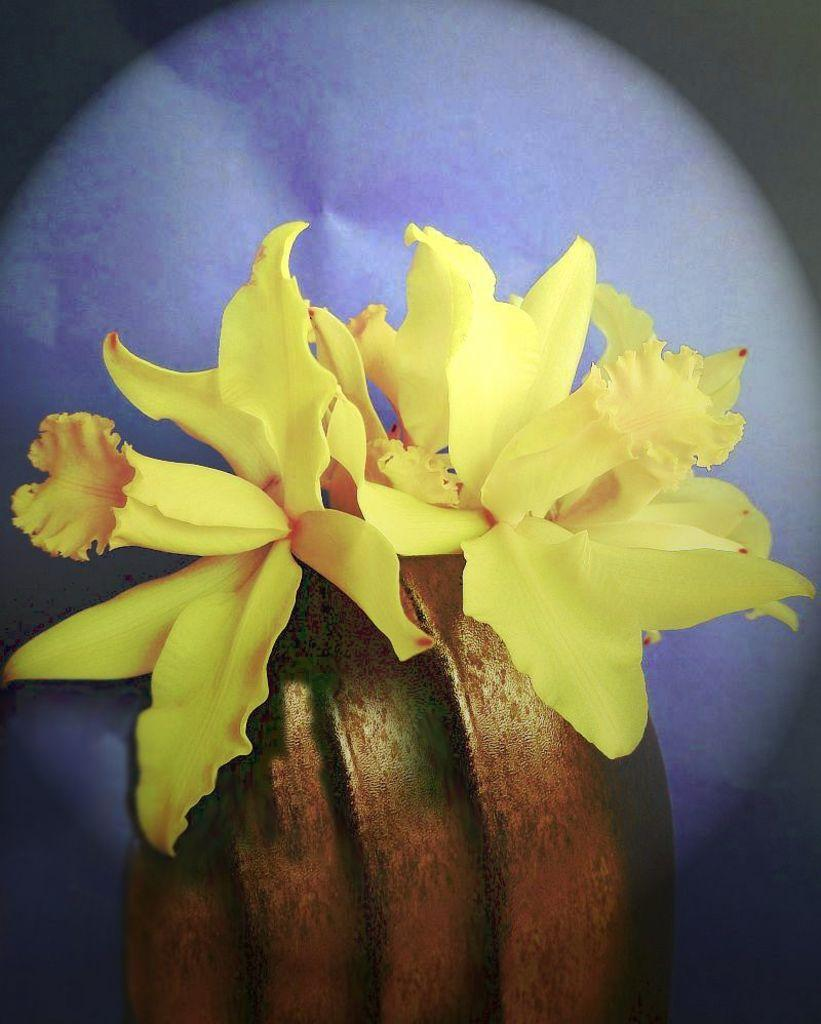What is present in the image? There are flowers in the image. Can you describe the background of the image? The background of the image is blurred. What type of connection can be seen between the flowers in the image? There is no connection between the flowers in the image, as they are individual flowers. 